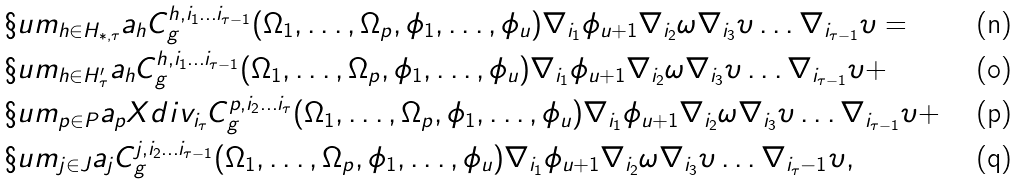Convert formula to latex. <formula><loc_0><loc_0><loc_500><loc_500>& \S u m _ { h \in H _ { * , \tau } } a _ { h } C ^ { h , i _ { 1 } \dots i _ { \tau - 1 } } _ { g } ( \Omega _ { 1 } , \dots , \Omega _ { p } , \phi _ { 1 } , \dots , \phi _ { u } ) \nabla _ { i _ { 1 } } \phi _ { u + 1 } \nabla _ { i _ { 2 } } \omega \nabla _ { i _ { 3 } } \upsilon \dots \nabla _ { i _ { \tau - 1 } } \upsilon = \\ & \S u m _ { h \in H ^ { \prime } _ { \tau } } a _ { h } C ^ { h , i _ { 1 } \dots i _ { \tau - 1 } } _ { g } ( \Omega _ { 1 } , \dots , \Omega _ { p } , \phi _ { 1 } , \dots , \phi _ { u } ) \nabla _ { i _ { 1 } } \phi _ { u + 1 } \nabla _ { i _ { 2 } } \omega \nabla _ { i _ { 3 } } \upsilon \dots \nabla _ { i _ { \tau - 1 } } \upsilon + \\ & \S u m _ { p \in P } a _ { p } X d i v _ { i _ { \tau } } C ^ { p , i _ { 2 } \dots i _ { \tau } } _ { g } ( \Omega _ { 1 } , \dots , \Omega _ { p } , \phi _ { 1 } , \dots , \phi _ { u } ) \nabla _ { i _ { 1 } } \phi _ { u + 1 } \nabla _ { i _ { 2 } } \omega \nabla _ { i _ { 3 } } \upsilon \dots \nabla _ { i _ { \tau - 1 } } \upsilon + \\ & \S u m _ { j \in J } a _ { j } C ^ { j , i _ { 2 } \dots i _ { \tau - 1 } } _ { g } ( \Omega _ { 1 } , \dots , \Omega _ { p } , \phi _ { 1 } , \dots , \phi _ { u } ) \nabla _ { i _ { 1 } } \phi _ { u + 1 } \nabla _ { i _ { 2 } } \omega \nabla _ { i _ { 3 } } \upsilon \dots \nabla _ { i _ { \tau } - 1 } \upsilon ,</formula> 